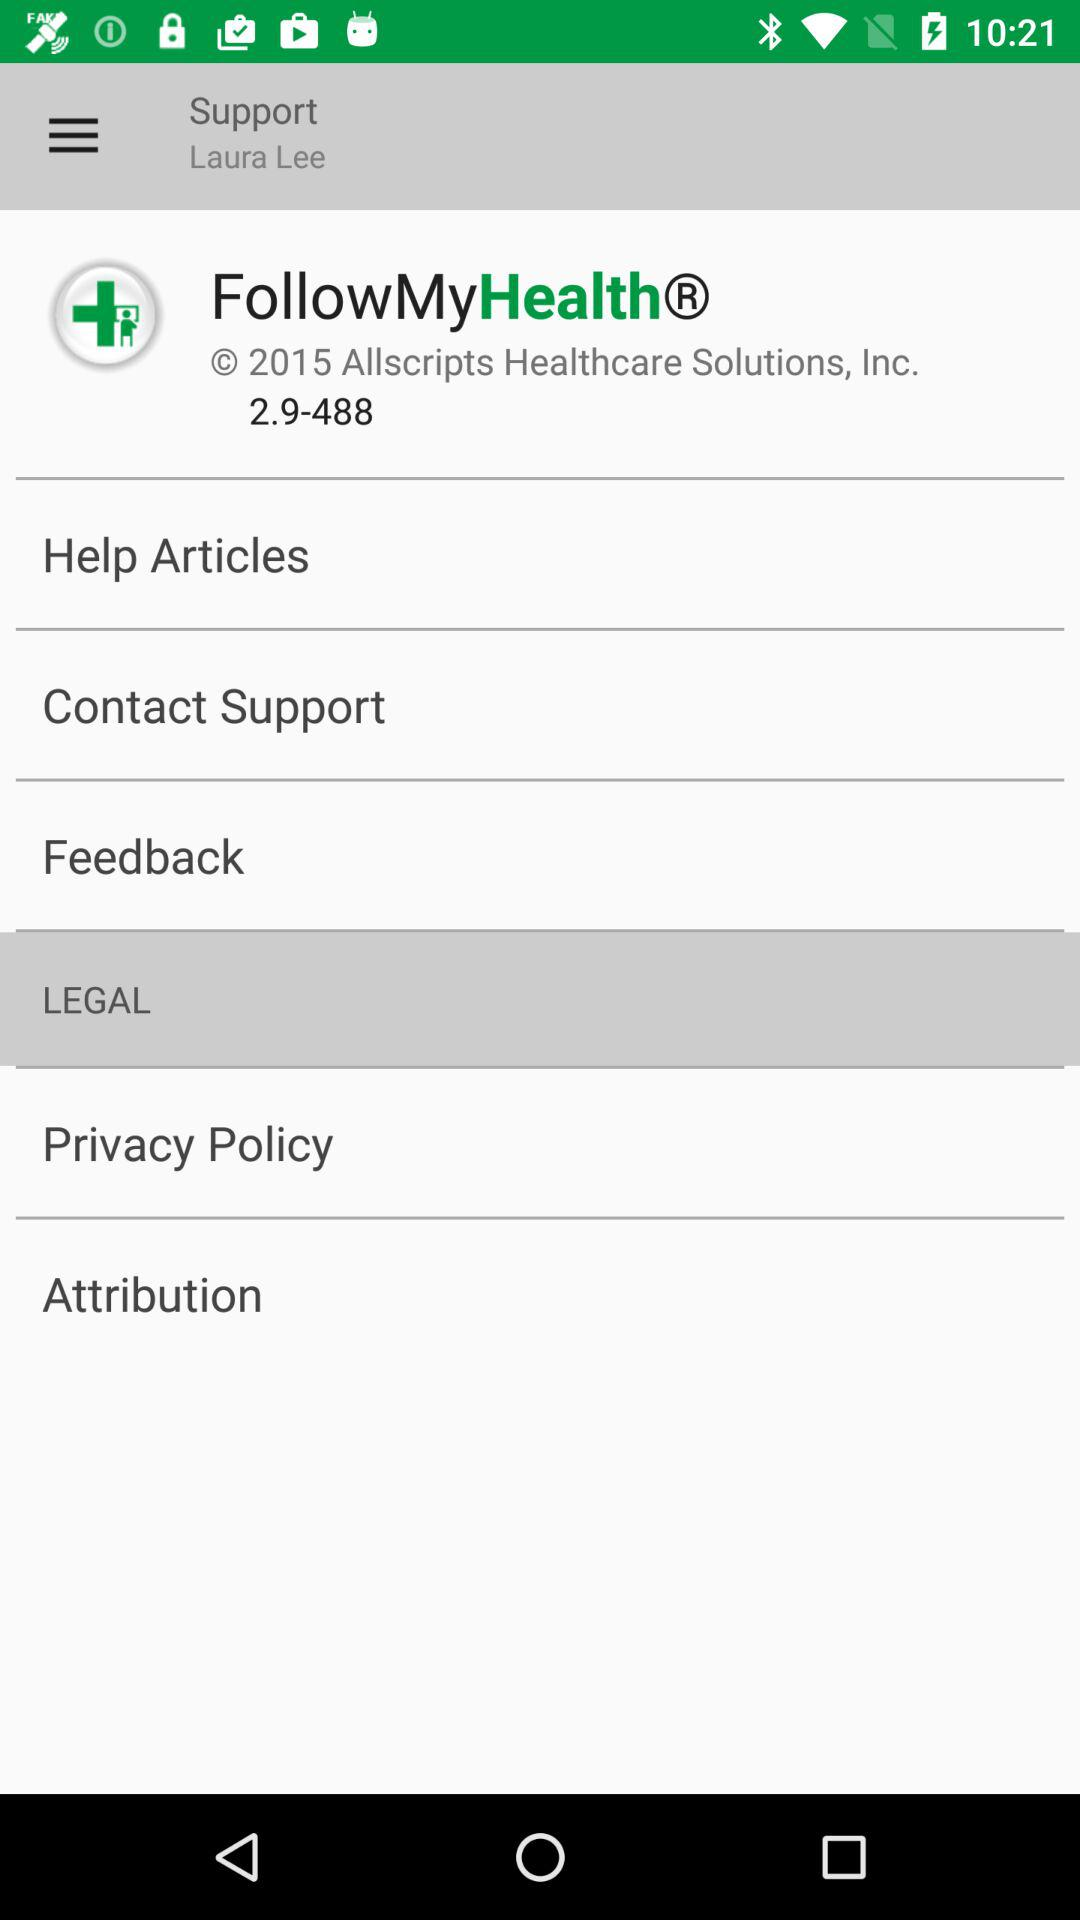What is the version of the application? The version is 2.9-488. 